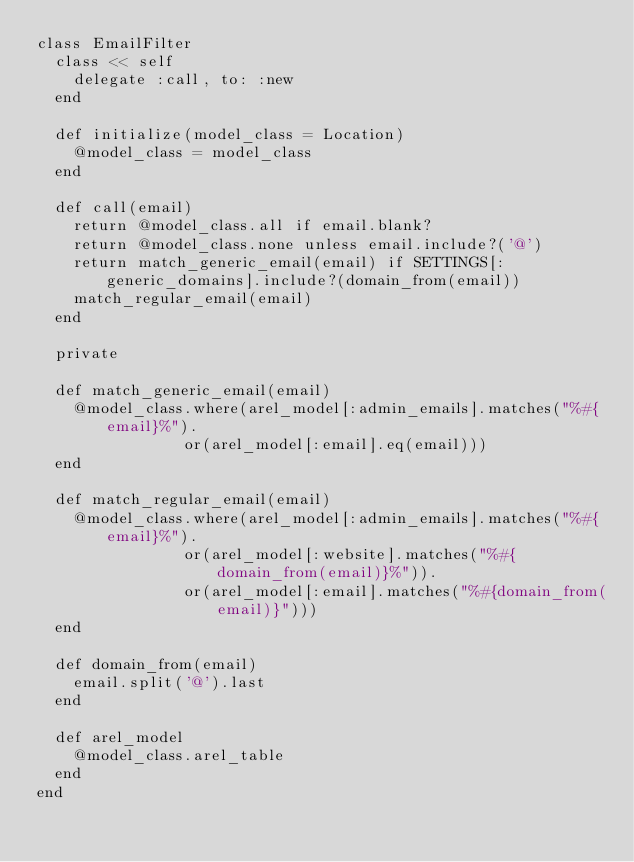<code> <loc_0><loc_0><loc_500><loc_500><_Ruby_>class EmailFilter
  class << self
    delegate :call, to: :new
  end

  def initialize(model_class = Location)
    @model_class = model_class
  end

  def call(email)
    return @model_class.all if email.blank?
    return @model_class.none unless email.include?('@')
    return match_generic_email(email) if SETTINGS[:generic_domains].include?(domain_from(email))
    match_regular_email(email)
  end

  private

  def match_generic_email(email)
    @model_class.where(arel_model[:admin_emails].matches("%#{email}%").
                or(arel_model[:email].eq(email)))
  end

  def match_regular_email(email)
    @model_class.where(arel_model[:admin_emails].matches("%#{email}%").
                or(arel_model[:website].matches("%#{domain_from(email)}%")).
                or(arel_model[:email].matches("%#{domain_from(email)}")))
  end

  def domain_from(email)
    email.split('@').last
  end

  def arel_model
    @model_class.arel_table
  end
end
</code> 